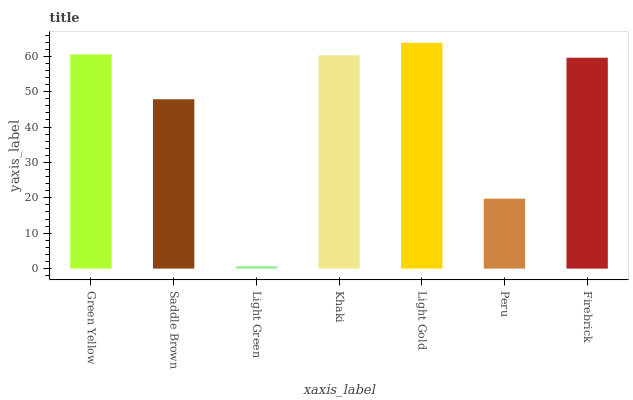Is Light Green the minimum?
Answer yes or no. Yes. Is Light Gold the maximum?
Answer yes or no. Yes. Is Saddle Brown the minimum?
Answer yes or no. No. Is Saddle Brown the maximum?
Answer yes or no. No. Is Green Yellow greater than Saddle Brown?
Answer yes or no. Yes. Is Saddle Brown less than Green Yellow?
Answer yes or no. Yes. Is Saddle Brown greater than Green Yellow?
Answer yes or no. No. Is Green Yellow less than Saddle Brown?
Answer yes or no. No. Is Firebrick the high median?
Answer yes or no. Yes. Is Firebrick the low median?
Answer yes or no. Yes. Is Khaki the high median?
Answer yes or no. No. Is Light Gold the low median?
Answer yes or no. No. 